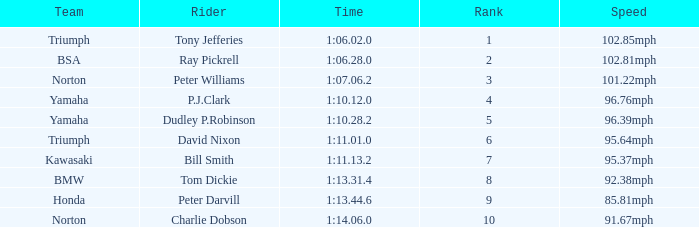At 96.76mph speed, what is the Time? 1:10.12.0. 